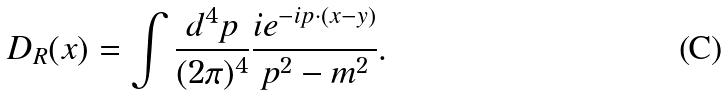<formula> <loc_0><loc_0><loc_500><loc_500>D _ { R } ( x ) = \int \frac { d ^ { 4 } p } { ( 2 \pi ) ^ { 4 } } \frac { i e ^ { - i p \cdot ( x - y ) } } { p ^ { 2 } - m ^ { 2 } } .</formula> 